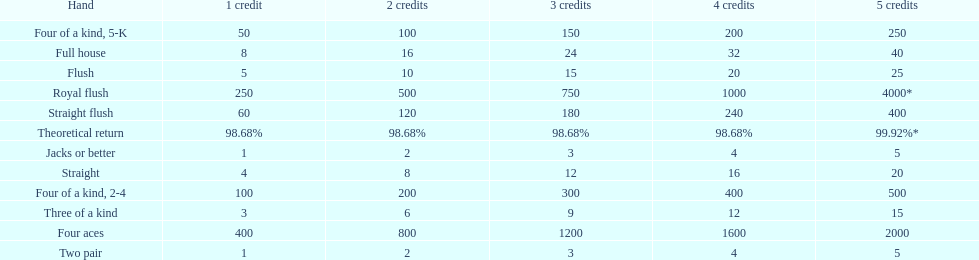Which is a higher standing hand: a straight or a flush? Flush. 